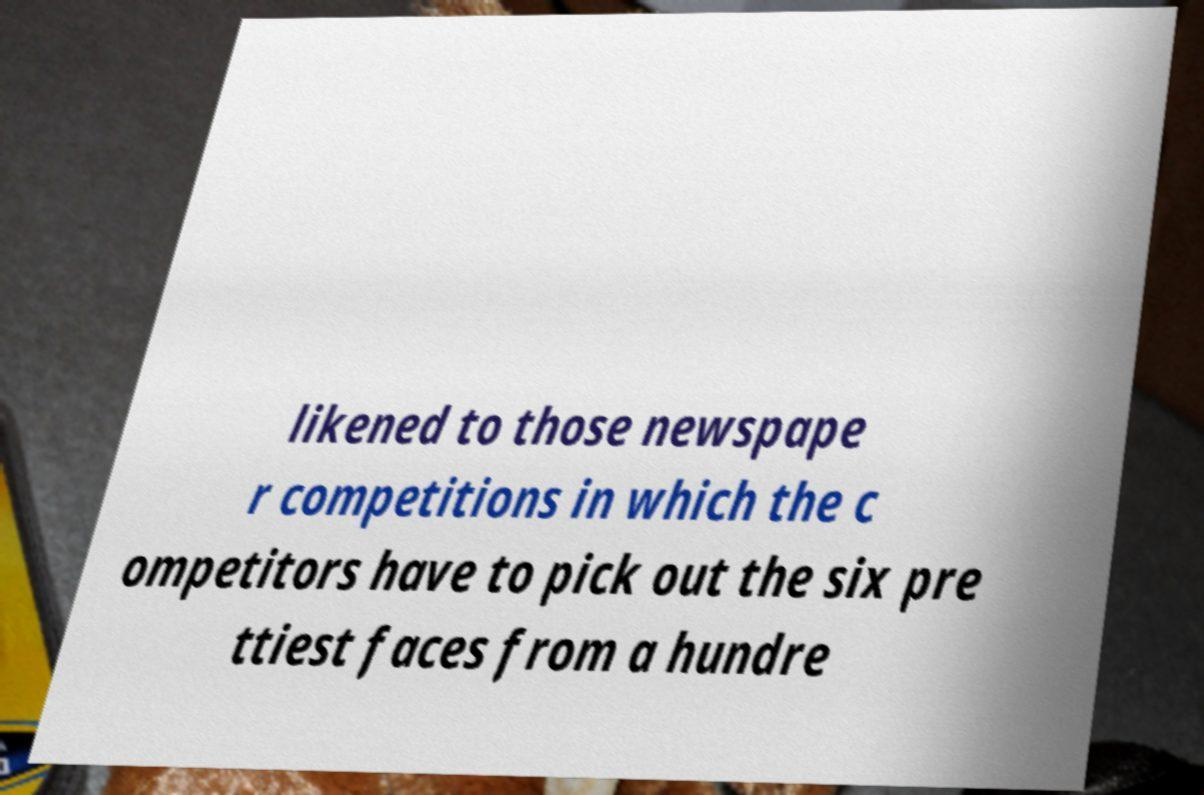Please read and relay the text visible in this image. What does it say? likened to those newspape r competitions in which the c ompetitors have to pick out the six pre ttiest faces from a hundre 